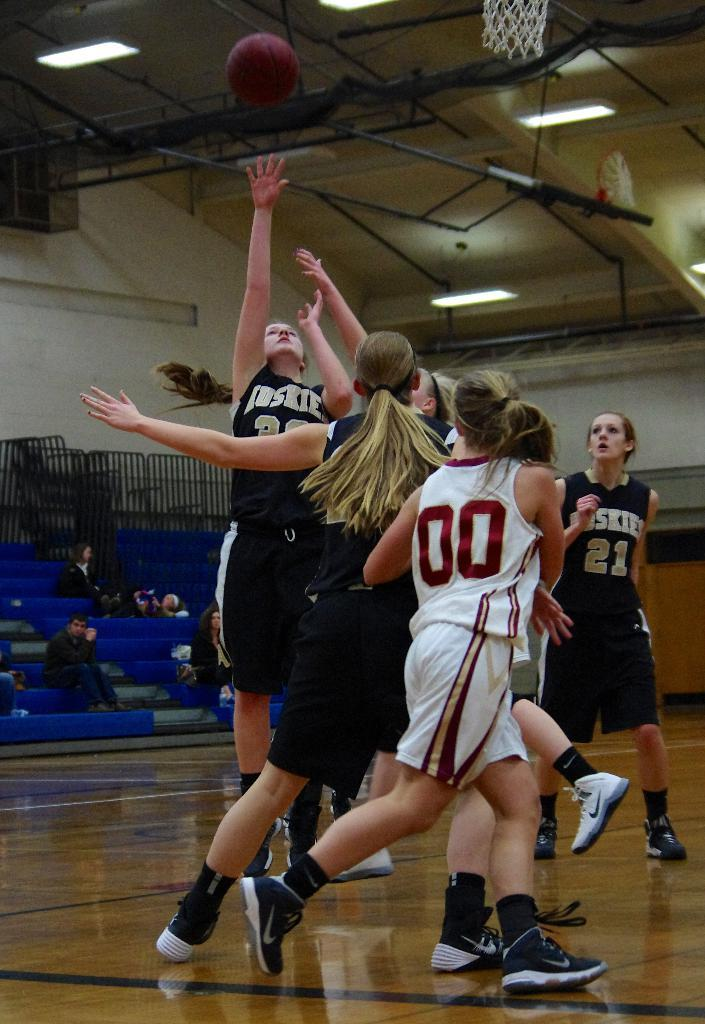<image>
Share a concise interpretation of the image provided. Women in Huskies uniforms playing basketball against a team in white uniforms. 